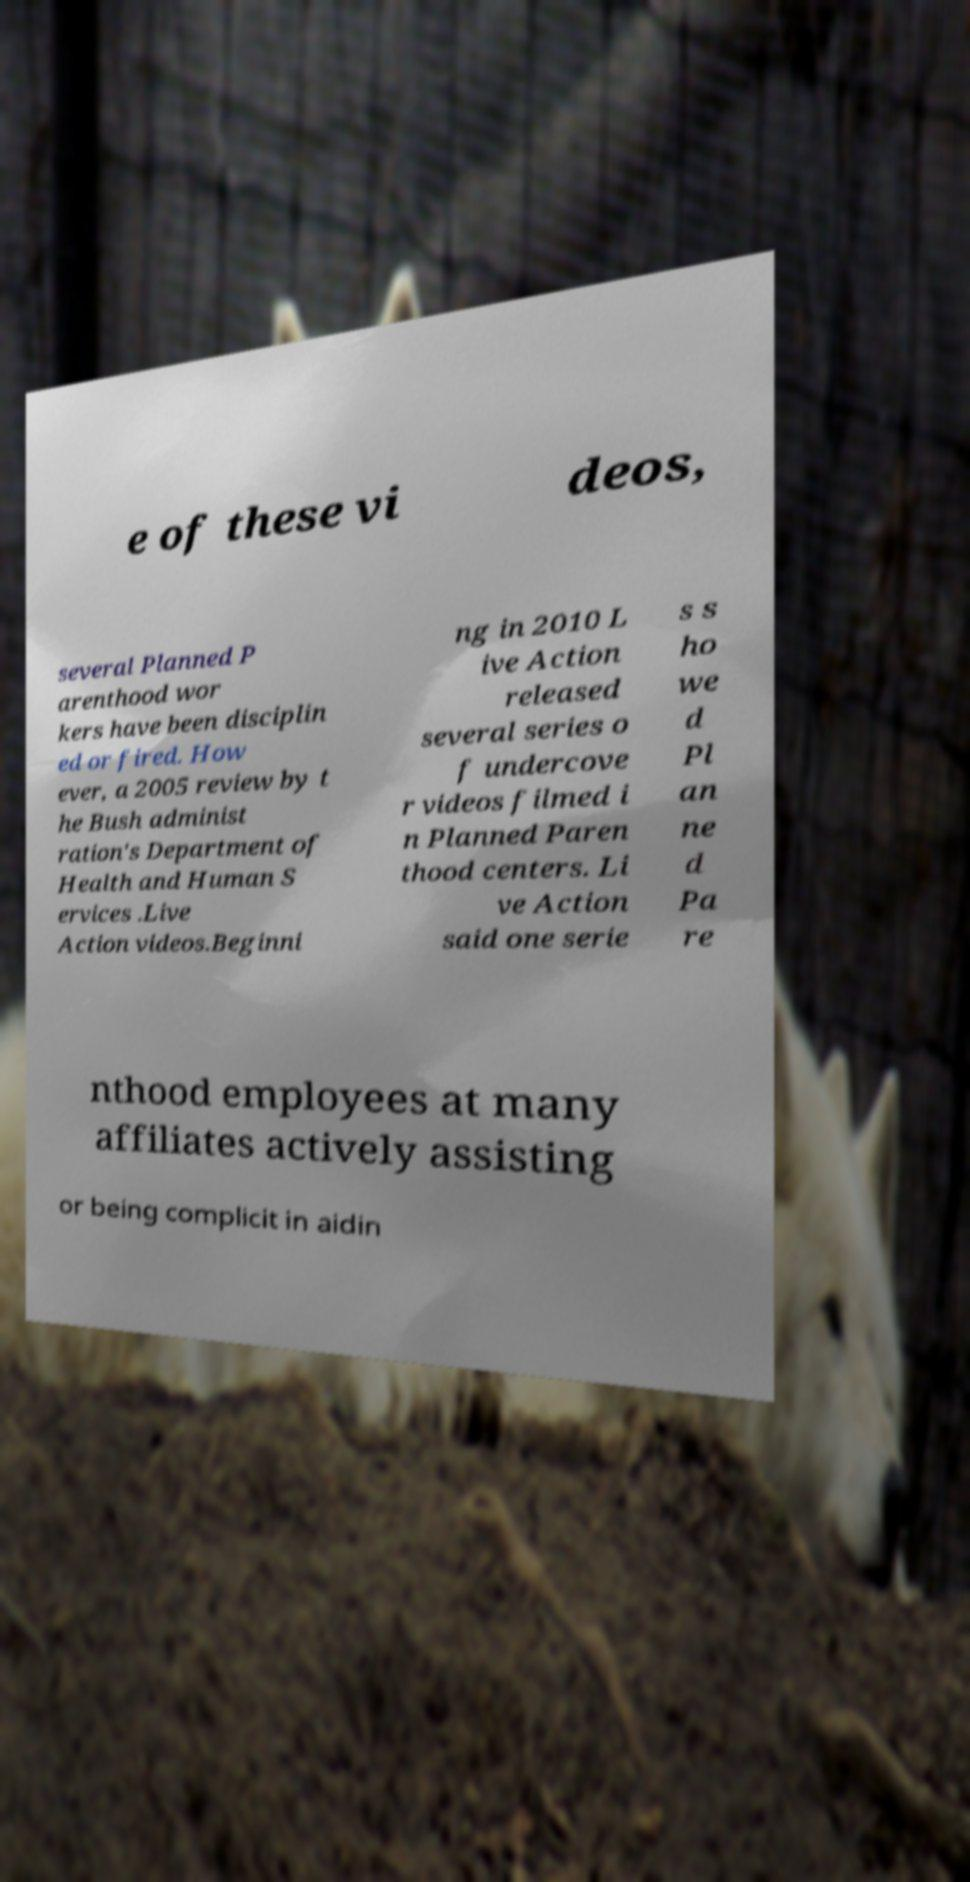Could you extract and type out the text from this image? e of these vi deos, several Planned P arenthood wor kers have been disciplin ed or fired. How ever, a 2005 review by t he Bush administ ration's Department of Health and Human S ervices .Live Action videos.Beginni ng in 2010 L ive Action released several series o f undercove r videos filmed i n Planned Paren thood centers. Li ve Action said one serie s s ho we d Pl an ne d Pa re nthood employees at many affiliates actively assisting or being complicit in aidin 